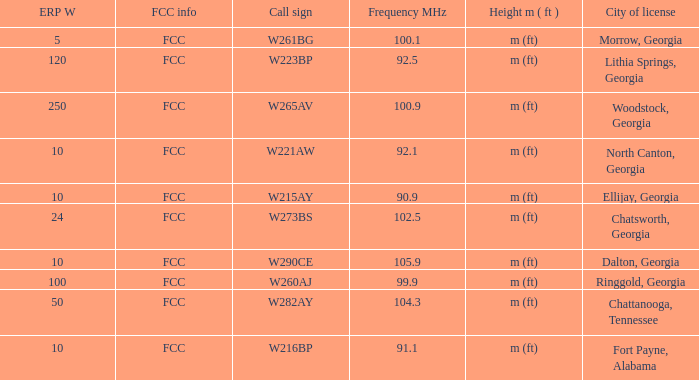How many ERP W is it that has a Call sign of w273bs? 24.0. 